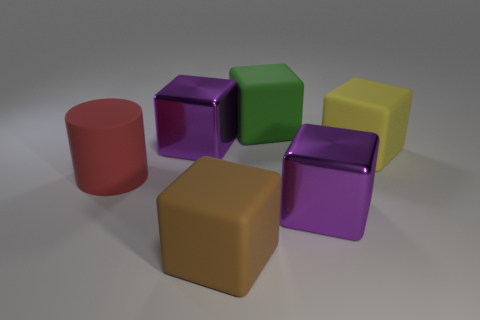Subtract 1 cubes. How many cubes are left? 4 Subtract all red blocks. Subtract all purple cylinders. How many blocks are left? 5 Add 4 large metallic objects. How many objects exist? 10 Subtract all blocks. How many objects are left? 1 Subtract 1 red cylinders. How many objects are left? 5 Subtract all brown metal cylinders. Subtract all matte cylinders. How many objects are left? 5 Add 6 brown cubes. How many brown cubes are left? 7 Add 6 big purple rubber balls. How many big purple rubber balls exist? 6 